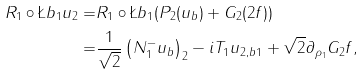Convert formula to latex. <formula><loc_0><loc_0><loc_500><loc_500>R _ { 1 } \circ \L b _ { 1 } u _ { 2 } = & R _ { 1 } \circ \L b _ { 1 } ( P _ { 2 } ( u _ { b } ) + G _ { 2 } ( 2 f ) ) \\ = & \frac { 1 } { \sqrt { 2 } } \left ( N _ { 1 } ^ { - } u _ { b } \right ) _ { 2 } - i T _ { 1 } u _ { 2 , b 1 } + \sqrt { 2 } \partial _ { \rho _ { 1 } } G _ { 2 } f ,</formula> 